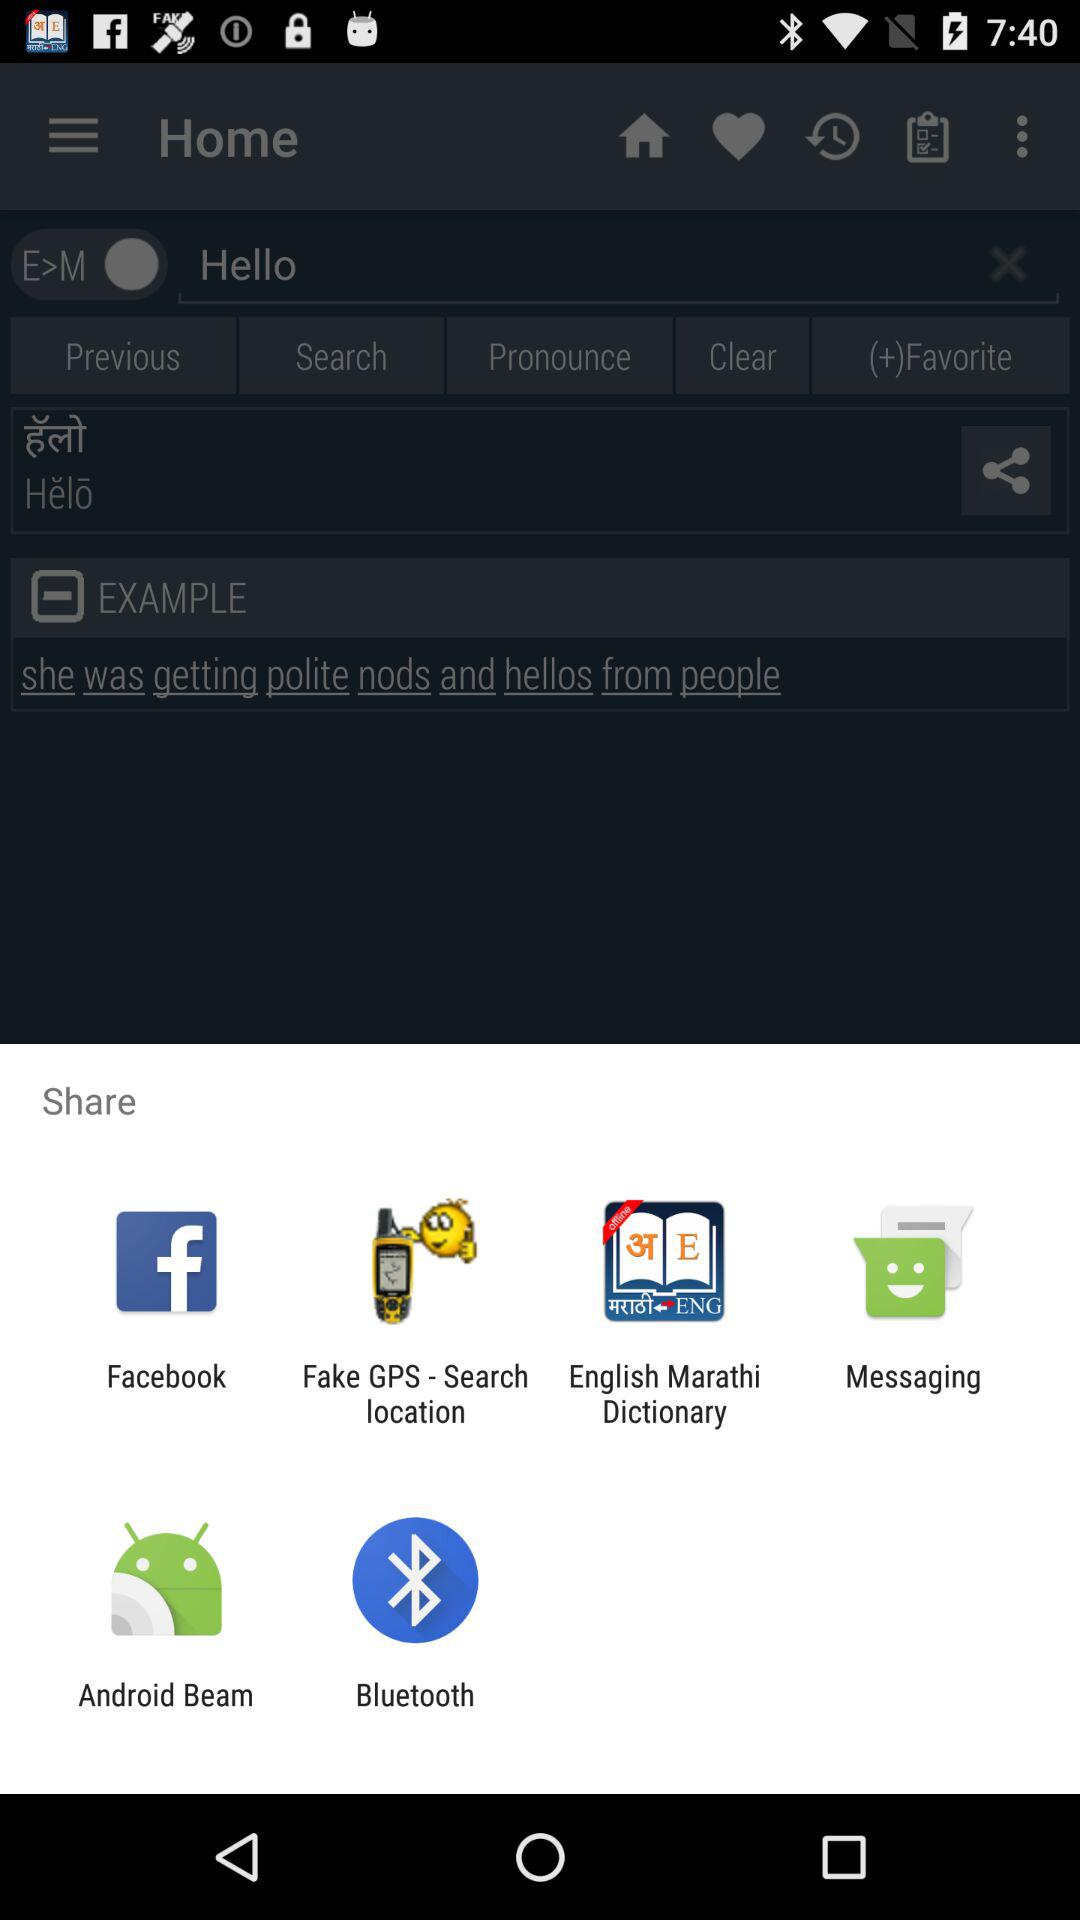What are the different options through which we can share? You can share through "Facebook", "Fake GPS - Search location", "English Marathi Dictionary", "Messaging", "Android Beam" and "Bluetooth". 